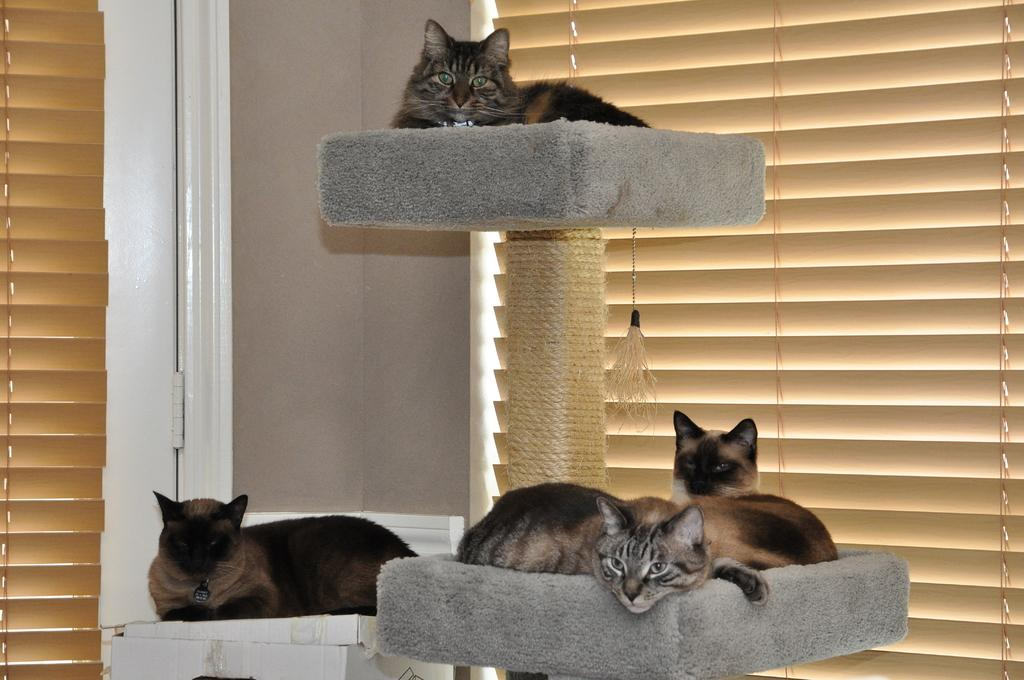What type of animals are in the image? There are cats in the image. Where are the cats located in the image? The cats are on objects in the image. What type of architectural feature is present in the image? There are shutters in the image. What can be seen through the shutters? There is a window in the image. What type of dish is the cook preparing for the daughter in the image? There is no cook, dish, or daughter present in the image; it features cats on objects with shutters and a window. 